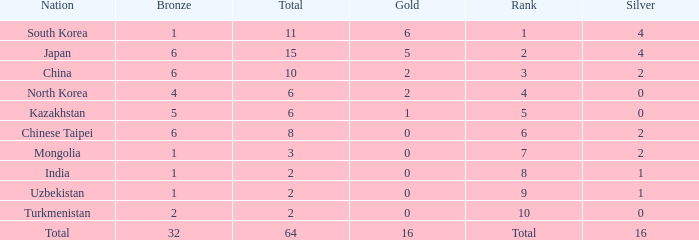How many Golds did Rank 10 get, with a Bronze larger than 2? 0.0. Parse the full table. {'header': ['Nation', 'Bronze', 'Total', 'Gold', 'Rank', 'Silver'], 'rows': [['South Korea', '1', '11', '6', '1', '4'], ['Japan', '6', '15', '5', '2', '4'], ['China', '6', '10', '2', '3', '2'], ['North Korea', '4', '6', '2', '4', '0'], ['Kazakhstan', '5', '6', '1', '5', '0'], ['Chinese Taipei', '6', '8', '0', '6', '2'], ['Mongolia', '1', '3', '0', '7', '2'], ['India', '1', '2', '0', '8', '1'], ['Uzbekistan', '1', '2', '0', '9', '1'], ['Turkmenistan', '2', '2', '0', '10', '0'], ['Total', '32', '64', '16', 'Total', '16']]} 